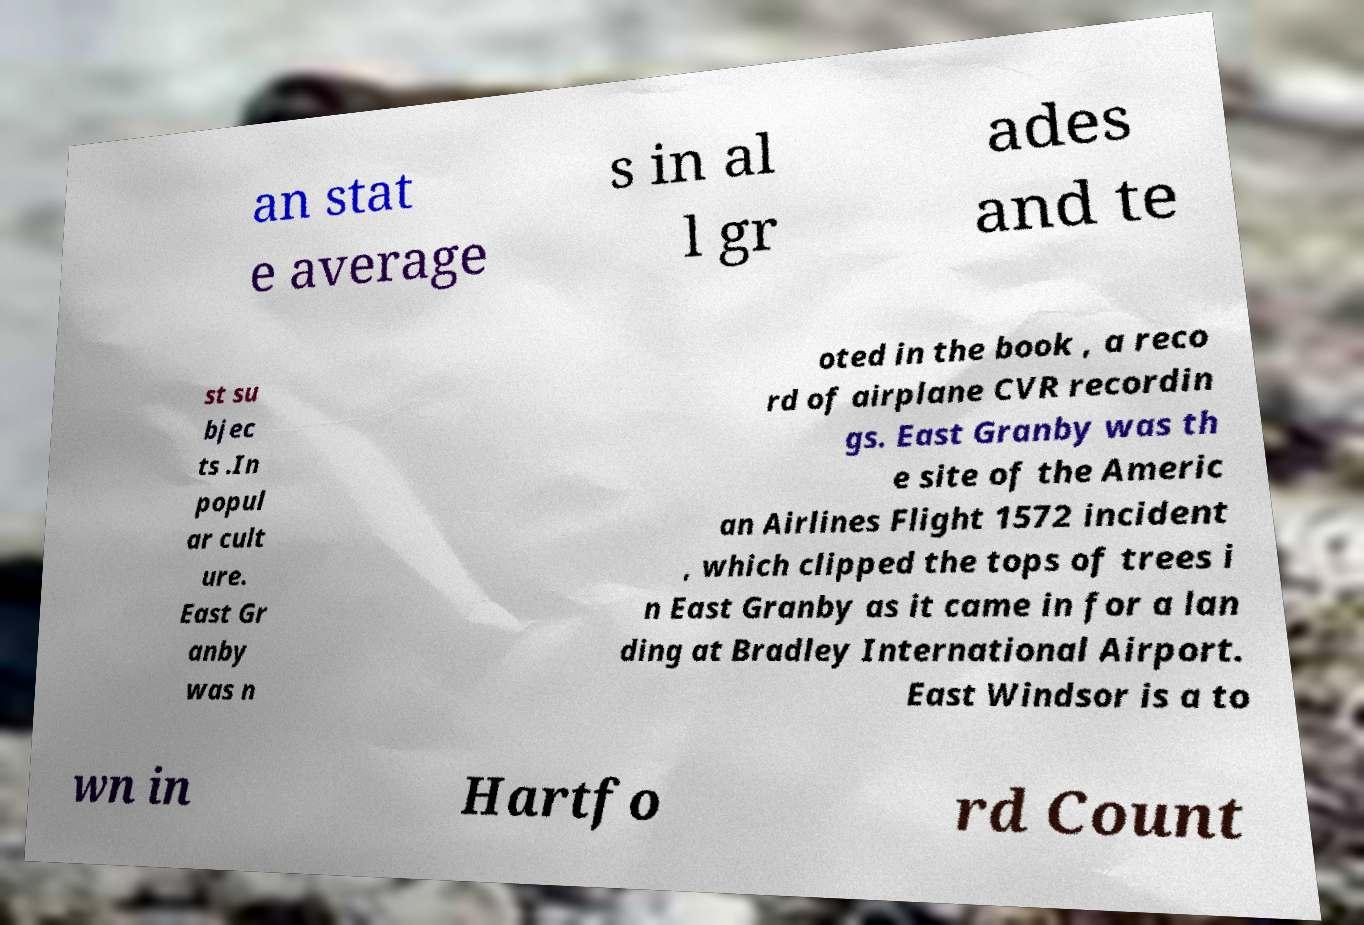What messages or text are displayed in this image? I need them in a readable, typed format. an stat e average s in al l gr ades and te st su bjec ts .In popul ar cult ure. East Gr anby was n oted in the book , a reco rd of airplane CVR recordin gs. East Granby was th e site of the Americ an Airlines Flight 1572 incident , which clipped the tops of trees i n East Granby as it came in for a lan ding at Bradley International Airport. East Windsor is a to wn in Hartfo rd Count 